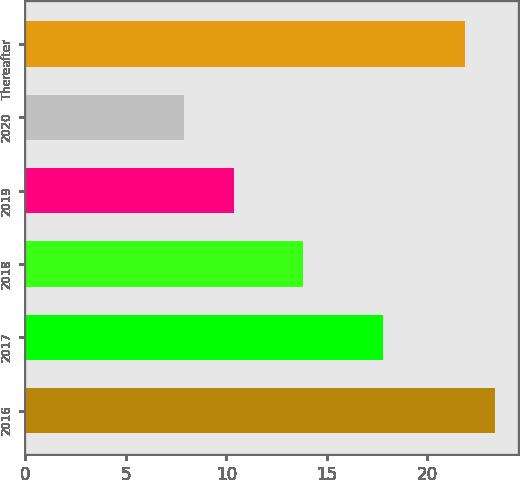Convert chart. <chart><loc_0><loc_0><loc_500><loc_500><bar_chart><fcel>2016<fcel>2017<fcel>2018<fcel>2019<fcel>2020<fcel>Thereafter<nl><fcel>23.36<fcel>17.8<fcel>13.8<fcel>10.4<fcel>7.9<fcel>21.9<nl></chart> 